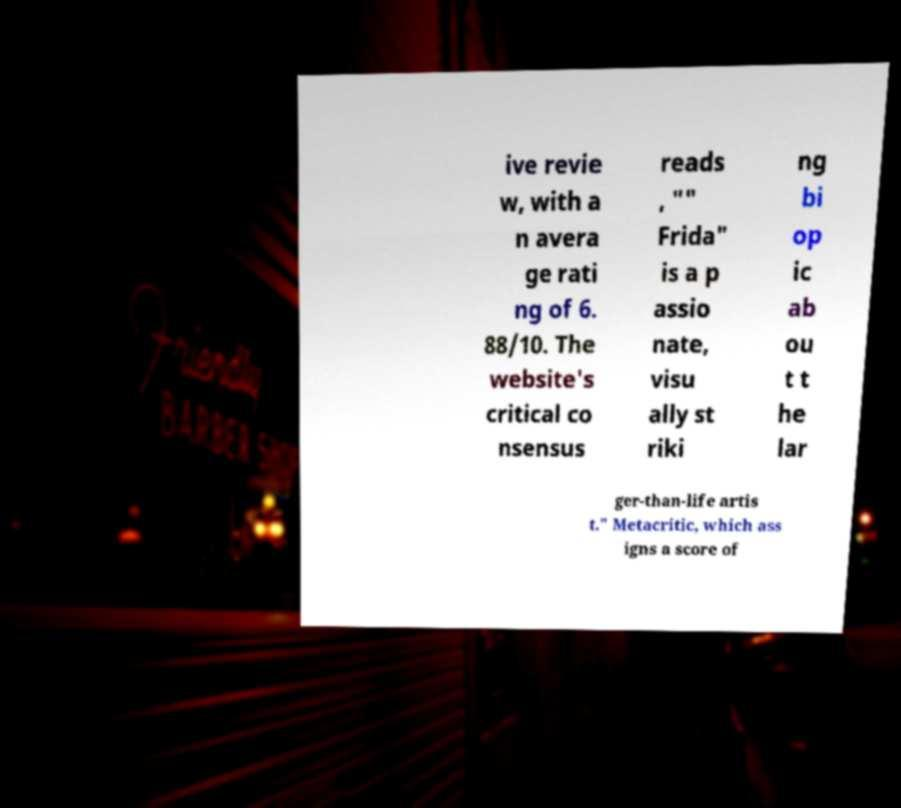Can you read and provide the text displayed in the image?This photo seems to have some interesting text. Can you extract and type it out for me? ive revie w, with a n avera ge rati ng of 6. 88/10. The website's critical co nsensus reads , "" Frida" is a p assio nate, visu ally st riki ng bi op ic ab ou t t he lar ger-than-life artis t." Metacritic, which ass igns a score of 